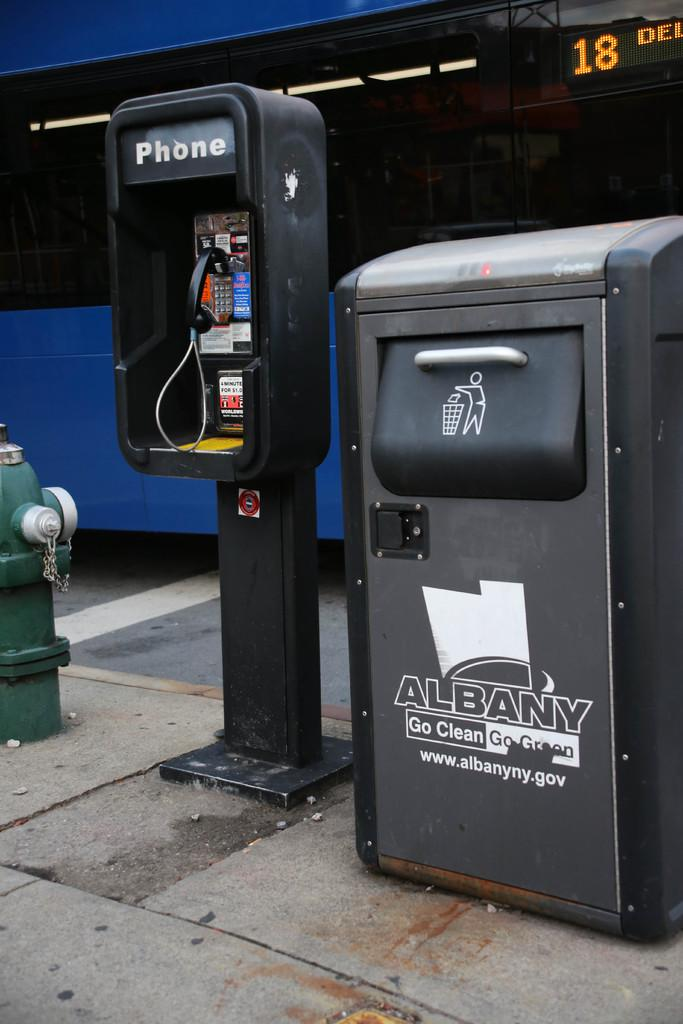<image>
Offer a succinct explanation of the picture presented. Pay phone on the left and a garbage pale to the right that says Albany Go Clean Go Green, www.albanyny.gov. 